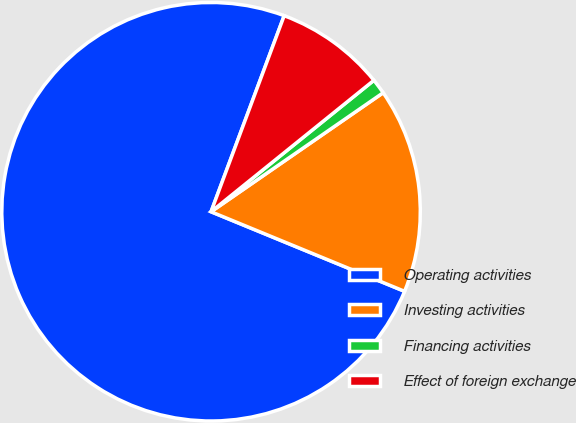<chart> <loc_0><loc_0><loc_500><loc_500><pie_chart><fcel>Operating activities<fcel>Investing activities<fcel>Financing activities<fcel>Effect of foreign exchange<nl><fcel>74.48%<fcel>15.84%<fcel>1.18%<fcel>8.51%<nl></chart> 